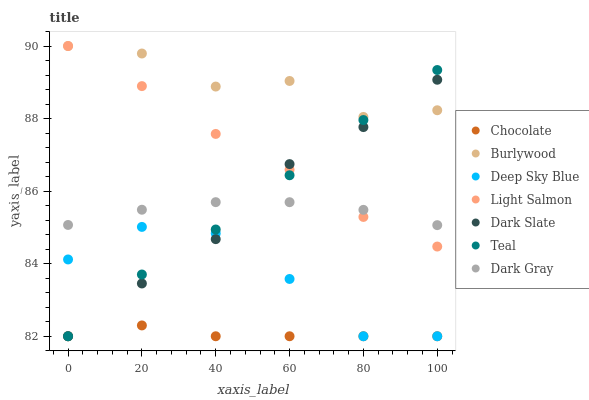Does Chocolate have the minimum area under the curve?
Answer yes or no. Yes. Does Burlywood have the maximum area under the curve?
Answer yes or no. Yes. Does Deep Sky Blue have the minimum area under the curve?
Answer yes or no. No. Does Deep Sky Blue have the maximum area under the curve?
Answer yes or no. No. Is Dark Gray the smoothest?
Answer yes or no. Yes. Is Burlywood the roughest?
Answer yes or no. Yes. Is Deep Sky Blue the smoothest?
Answer yes or no. No. Is Deep Sky Blue the roughest?
Answer yes or no. No. Does Deep Sky Blue have the lowest value?
Answer yes or no. Yes. Does Burlywood have the lowest value?
Answer yes or no. No. Does Burlywood have the highest value?
Answer yes or no. Yes. Does Deep Sky Blue have the highest value?
Answer yes or no. No. Is Dark Gray less than Burlywood?
Answer yes or no. Yes. Is Burlywood greater than Dark Gray?
Answer yes or no. Yes. Does Light Salmon intersect Dark Slate?
Answer yes or no. Yes. Is Light Salmon less than Dark Slate?
Answer yes or no. No. Is Light Salmon greater than Dark Slate?
Answer yes or no. No. Does Dark Gray intersect Burlywood?
Answer yes or no. No. 